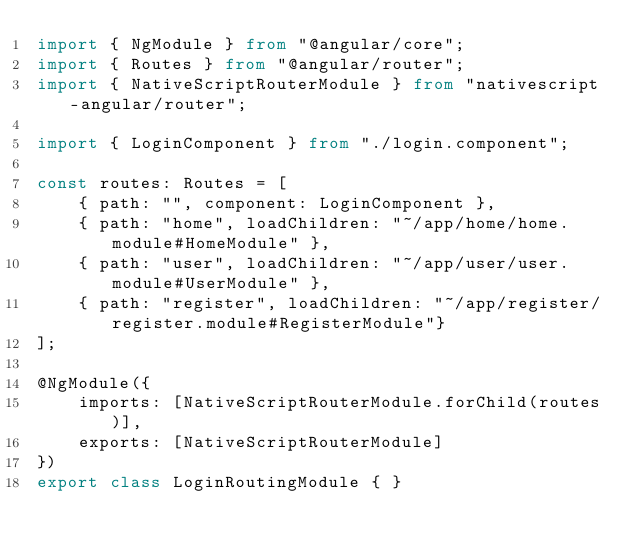Convert code to text. <code><loc_0><loc_0><loc_500><loc_500><_TypeScript_>import { NgModule } from "@angular/core";
import { Routes } from "@angular/router";
import { NativeScriptRouterModule } from "nativescript-angular/router";

import { LoginComponent } from "./login.component";

const routes: Routes = [
    { path: "", component: LoginComponent },
    { path: "home", loadChildren: "~/app/home/home.module#HomeModule" },
    { path: "user", loadChildren: "~/app/user/user.module#UserModule" },
    { path: "register", loadChildren: "~/app/register/register.module#RegisterModule"}
];

@NgModule({
    imports: [NativeScriptRouterModule.forChild(routes)],
    exports: [NativeScriptRouterModule]
})
export class LoginRoutingModule { }
</code> 